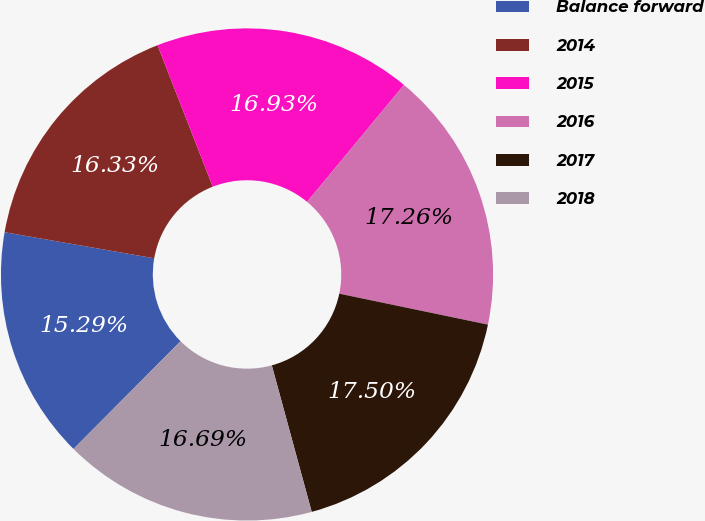Convert chart to OTSL. <chart><loc_0><loc_0><loc_500><loc_500><pie_chart><fcel>Balance forward<fcel>2014<fcel>2015<fcel>2016<fcel>2017<fcel>2018<nl><fcel>15.29%<fcel>16.33%<fcel>16.93%<fcel>17.26%<fcel>17.5%<fcel>16.69%<nl></chart> 